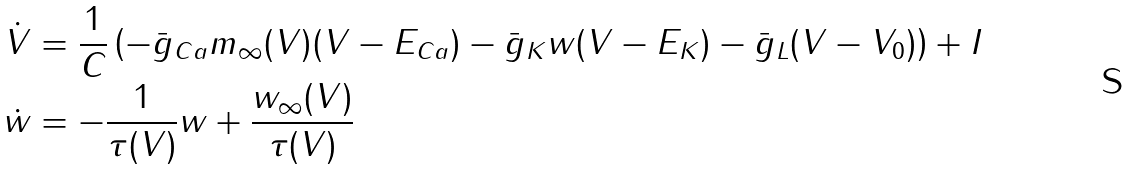<formula> <loc_0><loc_0><loc_500><loc_500>\dot { V } & = \frac { 1 } { C } \left ( - \bar { g } _ { C a } m _ { \infty } ( V ) ( V - E _ { C a } ) - \bar { g } _ { K } w ( V - E _ { K } ) - \bar { g } _ { L } ( V - V _ { 0 } ) \right ) + I \\ \dot { w } & = - \frac { 1 } { \tau ( V ) } w + \frac { w _ { \infty } ( V ) } { \tau ( V ) }</formula> 